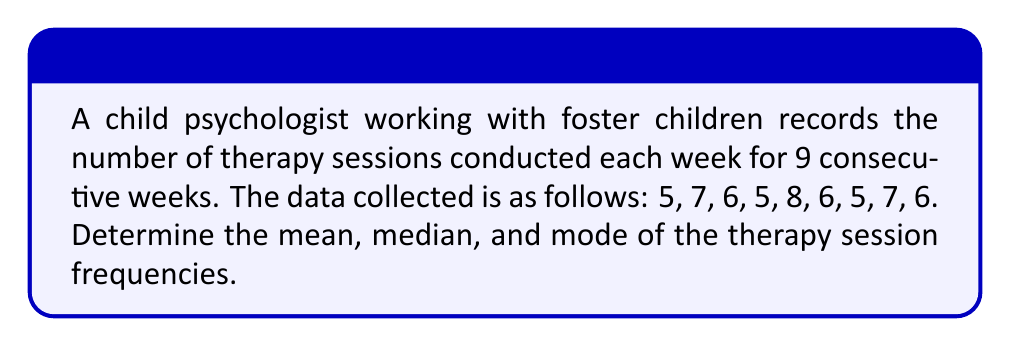Teach me how to tackle this problem. To solve this problem, we need to calculate the mean, median, and mode separately.

1. Mean:
The mean is the average of all values. To calculate it, we sum up all the values and divide by the number of data points.

$$ \text{Mean} = \frac{\sum_{i=1}^{n} x_i}{n} $$

Where $x_i$ represents each value and $n$ is the total number of values.

$$ \text{Mean} = \frac{5 + 7 + 6 + 5 + 8 + 6 + 5 + 7 + 6}{9} = \frac{55}{9} \approx 6.11 $$

2. Median:
The median is the middle value when the data is arranged in ascending or descending order. First, let's order the data:

5, 5, 5, 6, 6, 6, 7, 7, 8

With 9 data points, the median is the 5th value ($(n+1)/2 = (9+1)/2 = 5$).

Median = 6

3. Mode:
The mode is the value that appears most frequently in the dataset.

Counting the occurrences:
5 appears 3 times
6 appears 3 times
7 appears 2 times
8 appears 1 time

Both 5 and 6 appear most frequently (3 times each), so there are two modes.
Answer: Mean: $6.11$ (rounded to two decimal places)
Median: $6$
Mode: $5$ and $6$ (bimodal) 